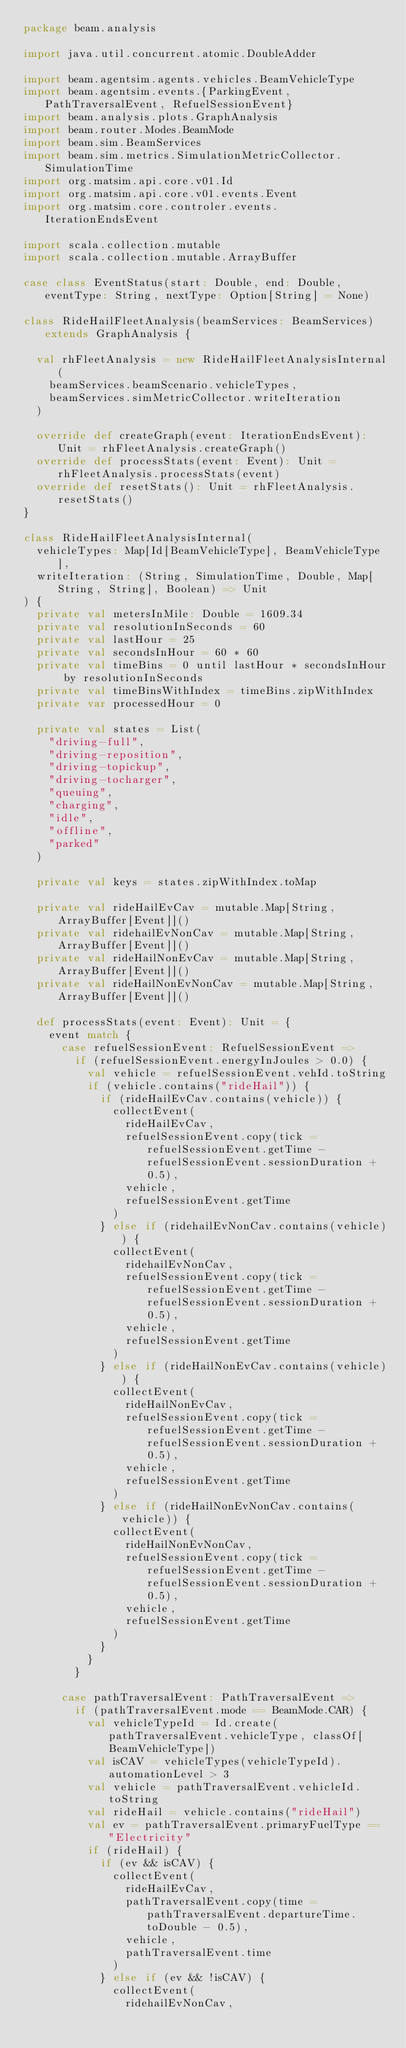Convert code to text. <code><loc_0><loc_0><loc_500><loc_500><_Scala_>package beam.analysis

import java.util.concurrent.atomic.DoubleAdder

import beam.agentsim.agents.vehicles.BeamVehicleType
import beam.agentsim.events.{ParkingEvent, PathTraversalEvent, RefuelSessionEvent}
import beam.analysis.plots.GraphAnalysis
import beam.router.Modes.BeamMode
import beam.sim.BeamServices
import beam.sim.metrics.SimulationMetricCollector.SimulationTime
import org.matsim.api.core.v01.Id
import org.matsim.api.core.v01.events.Event
import org.matsim.core.controler.events.IterationEndsEvent

import scala.collection.mutable
import scala.collection.mutable.ArrayBuffer

case class EventStatus(start: Double, end: Double, eventType: String, nextType: Option[String] = None)

class RideHailFleetAnalysis(beamServices: BeamServices) extends GraphAnalysis {

  val rhFleetAnalysis = new RideHailFleetAnalysisInternal(
    beamServices.beamScenario.vehicleTypes,
    beamServices.simMetricCollector.writeIteration
  )

  override def createGraph(event: IterationEndsEvent): Unit = rhFleetAnalysis.createGraph()
  override def processStats(event: Event): Unit = rhFleetAnalysis.processStats(event)
  override def resetStats(): Unit = rhFleetAnalysis.resetStats()
}

class RideHailFleetAnalysisInternal(
  vehicleTypes: Map[Id[BeamVehicleType], BeamVehicleType],
  writeIteration: (String, SimulationTime, Double, Map[String, String], Boolean) => Unit
) {
  private val metersInMile: Double = 1609.34
  private val resolutionInSeconds = 60
  private val lastHour = 25
  private val secondsInHour = 60 * 60
  private val timeBins = 0 until lastHour * secondsInHour by resolutionInSeconds
  private val timeBinsWithIndex = timeBins.zipWithIndex
  private var processedHour = 0

  private val states = List(
    "driving-full",
    "driving-reposition",
    "driving-topickup",
    "driving-tocharger",
    "queuing",
    "charging",
    "idle",
    "offline",
    "parked"
  )

  private val keys = states.zipWithIndex.toMap

  private val rideHailEvCav = mutable.Map[String, ArrayBuffer[Event]]()
  private val ridehailEvNonCav = mutable.Map[String, ArrayBuffer[Event]]()
  private val rideHailNonEvCav = mutable.Map[String, ArrayBuffer[Event]]()
  private val rideHailNonEvNonCav = mutable.Map[String, ArrayBuffer[Event]]()

  def processStats(event: Event): Unit = {
    event match {
      case refuelSessionEvent: RefuelSessionEvent =>
        if (refuelSessionEvent.energyInJoules > 0.0) {
          val vehicle = refuelSessionEvent.vehId.toString
          if (vehicle.contains("rideHail")) {
            if (rideHailEvCav.contains(vehicle)) {
              collectEvent(
                rideHailEvCav,
                refuelSessionEvent.copy(tick = refuelSessionEvent.getTime - refuelSessionEvent.sessionDuration + 0.5),
                vehicle,
                refuelSessionEvent.getTime
              )
            } else if (ridehailEvNonCav.contains(vehicle)) {
              collectEvent(
                ridehailEvNonCav,
                refuelSessionEvent.copy(tick = refuelSessionEvent.getTime - refuelSessionEvent.sessionDuration + 0.5),
                vehicle,
                refuelSessionEvent.getTime
              )
            } else if (rideHailNonEvCav.contains(vehicle)) {
              collectEvent(
                rideHailNonEvCav,
                refuelSessionEvent.copy(tick = refuelSessionEvent.getTime - refuelSessionEvent.sessionDuration + 0.5),
                vehicle,
                refuelSessionEvent.getTime
              )
            } else if (rideHailNonEvNonCav.contains(vehicle)) {
              collectEvent(
                rideHailNonEvNonCav,
                refuelSessionEvent.copy(tick = refuelSessionEvent.getTime - refuelSessionEvent.sessionDuration + 0.5),
                vehicle,
                refuelSessionEvent.getTime
              )
            }
          }
        }

      case pathTraversalEvent: PathTraversalEvent =>
        if (pathTraversalEvent.mode == BeamMode.CAR) {
          val vehicleTypeId = Id.create(pathTraversalEvent.vehicleType, classOf[BeamVehicleType])
          val isCAV = vehicleTypes(vehicleTypeId).automationLevel > 3
          val vehicle = pathTraversalEvent.vehicleId.toString
          val rideHail = vehicle.contains("rideHail")
          val ev = pathTraversalEvent.primaryFuelType == "Electricity"
          if (rideHail) {
            if (ev && isCAV) {
              collectEvent(
                rideHailEvCav,
                pathTraversalEvent.copy(time = pathTraversalEvent.departureTime.toDouble - 0.5),
                vehicle,
                pathTraversalEvent.time
              )
            } else if (ev && !isCAV) {
              collectEvent(
                ridehailEvNonCav,</code> 